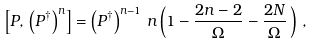<formula> <loc_0><loc_0><loc_500><loc_500>\left [ P , \, \left ( P ^ { \dagger } \right ) ^ { n } \right ] = \left ( P ^ { \dagger } \right ) ^ { n - 1 } \, n \left ( 1 - \frac { 2 n - 2 } { \Omega } - \frac { 2 N } { \Omega } \, \right ) \, ,</formula> 